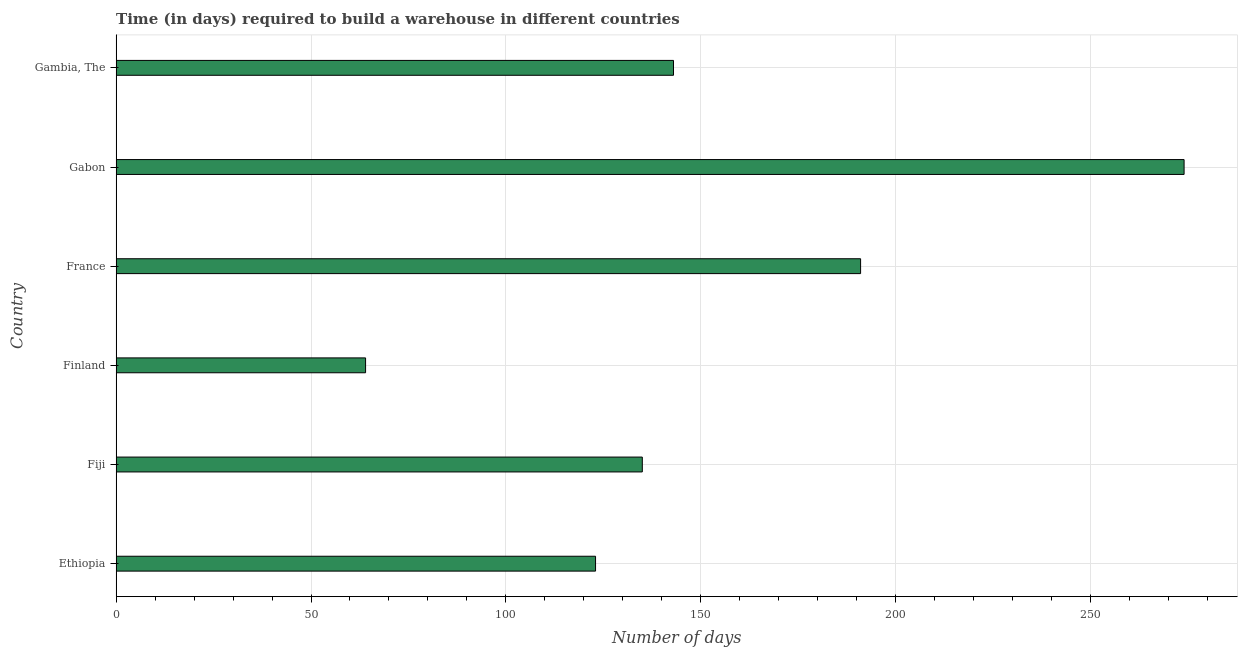Does the graph contain any zero values?
Ensure brevity in your answer.  No. Does the graph contain grids?
Your answer should be compact. Yes. What is the title of the graph?
Offer a very short reply. Time (in days) required to build a warehouse in different countries. What is the label or title of the X-axis?
Give a very brief answer. Number of days. What is the label or title of the Y-axis?
Keep it short and to the point. Country. What is the time required to build a warehouse in Gambia, The?
Give a very brief answer. 143. Across all countries, what is the maximum time required to build a warehouse?
Ensure brevity in your answer.  274. In which country was the time required to build a warehouse maximum?
Your response must be concise. Gabon. In which country was the time required to build a warehouse minimum?
Keep it short and to the point. Finland. What is the sum of the time required to build a warehouse?
Give a very brief answer. 930. What is the average time required to build a warehouse per country?
Provide a succinct answer. 155. What is the median time required to build a warehouse?
Make the answer very short. 139. In how many countries, is the time required to build a warehouse greater than 30 days?
Your answer should be very brief. 6. What is the ratio of the time required to build a warehouse in Ethiopia to that in Gambia, The?
Ensure brevity in your answer.  0.86. Is the difference between the time required to build a warehouse in Gabon and Gambia, The greater than the difference between any two countries?
Make the answer very short. No. What is the difference between the highest and the lowest time required to build a warehouse?
Offer a terse response. 210. How many bars are there?
Your response must be concise. 6. Are all the bars in the graph horizontal?
Provide a succinct answer. Yes. What is the difference between two consecutive major ticks on the X-axis?
Make the answer very short. 50. Are the values on the major ticks of X-axis written in scientific E-notation?
Ensure brevity in your answer.  No. What is the Number of days of Ethiopia?
Your response must be concise. 123. What is the Number of days in Fiji?
Your response must be concise. 135. What is the Number of days in Finland?
Offer a terse response. 64. What is the Number of days of France?
Your response must be concise. 191. What is the Number of days in Gabon?
Provide a succinct answer. 274. What is the Number of days in Gambia, The?
Give a very brief answer. 143. What is the difference between the Number of days in Ethiopia and France?
Provide a short and direct response. -68. What is the difference between the Number of days in Ethiopia and Gabon?
Your answer should be very brief. -151. What is the difference between the Number of days in Ethiopia and Gambia, The?
Keep it short and to the point. -20. What is the difference between the Number of days in Fiji and Finland?
Your response must be concise. 71. What is the difference between the Number of days in Fiji and France?
Keep it short and to the point. -56. What is the difference between the Number of days in Fiji and Gabon?
Offer a very short reply. -139. What is the difference between the Number of days in Fiji and Gambia, The?
Offer a very short reply. -8. What is the difference between the Number of days in Finland and France?
Provide a short and direct response. -127. What is the difference between the Number of days in Finland and Gabon?
Make the answer very short. -210. What is the difference between the Number of days in Finland and Gambia, The?
Provide a succinct answer. -79. What is the difference between the Number of days in France and Gabon?
Your answer should be compact. -83. What is the difference between the Number of days in Gabon and Gambia, The?
Offer a very short reply. 131. What is the ratio of the Number of days in Ethiopia to that in Fiji?
Offer a very short reply. 0.91. What is the ratio of the Number of days in Ethiopia to that in Finland?
Keep it short and to the point. 1.92. What is the ratio of the Number of days in Ethiopia to that in France?
Make the answer very short. 0.64. What is the ratio of the Number of days in Ethiopia to that in Gabon?
Ensure brevity in your answer.  0.45. What is the ratio of the Number of days in Ethiopia to that in Gambia, The?
Your response must be concise. 0.86. What is the ratio of the Number of days in Fiji to that in Finland?
Ensure brevity in your answer.  2.11. What is the ratio of the Number of days in Fiji to that in France?
Your answer should be compact. 0.71. What is the ratio of the Number of days in Fiji to that in Gabon?
Provide a succinct answer. 0.49. What is the ratio of the Number of days in Fiji to that in Gambia, The?
Keep it short and to the point. 0.94. What is the ratio of the Number of days in Finland to that in France?
Offer a terse response. 0.34. What is the ratio of the Number of days in Finland to that in Gabon?
Give a very brief answer. 0.23. What is the ratio of the Number of days in Finland to that in Gambia, The?
Your answer should be compact. 0.45. What is the ratio of the Number of days in France to that in Gabon?
Provide a short and direct response. 0.7. What is the ratio of the Number of days in France to that in Gambia, The?
Your answer should be compact. 1.34. What is the ratio of the Number of days in Gabon to that in Gambia, The?
Give a very brief answer. 1.92. 